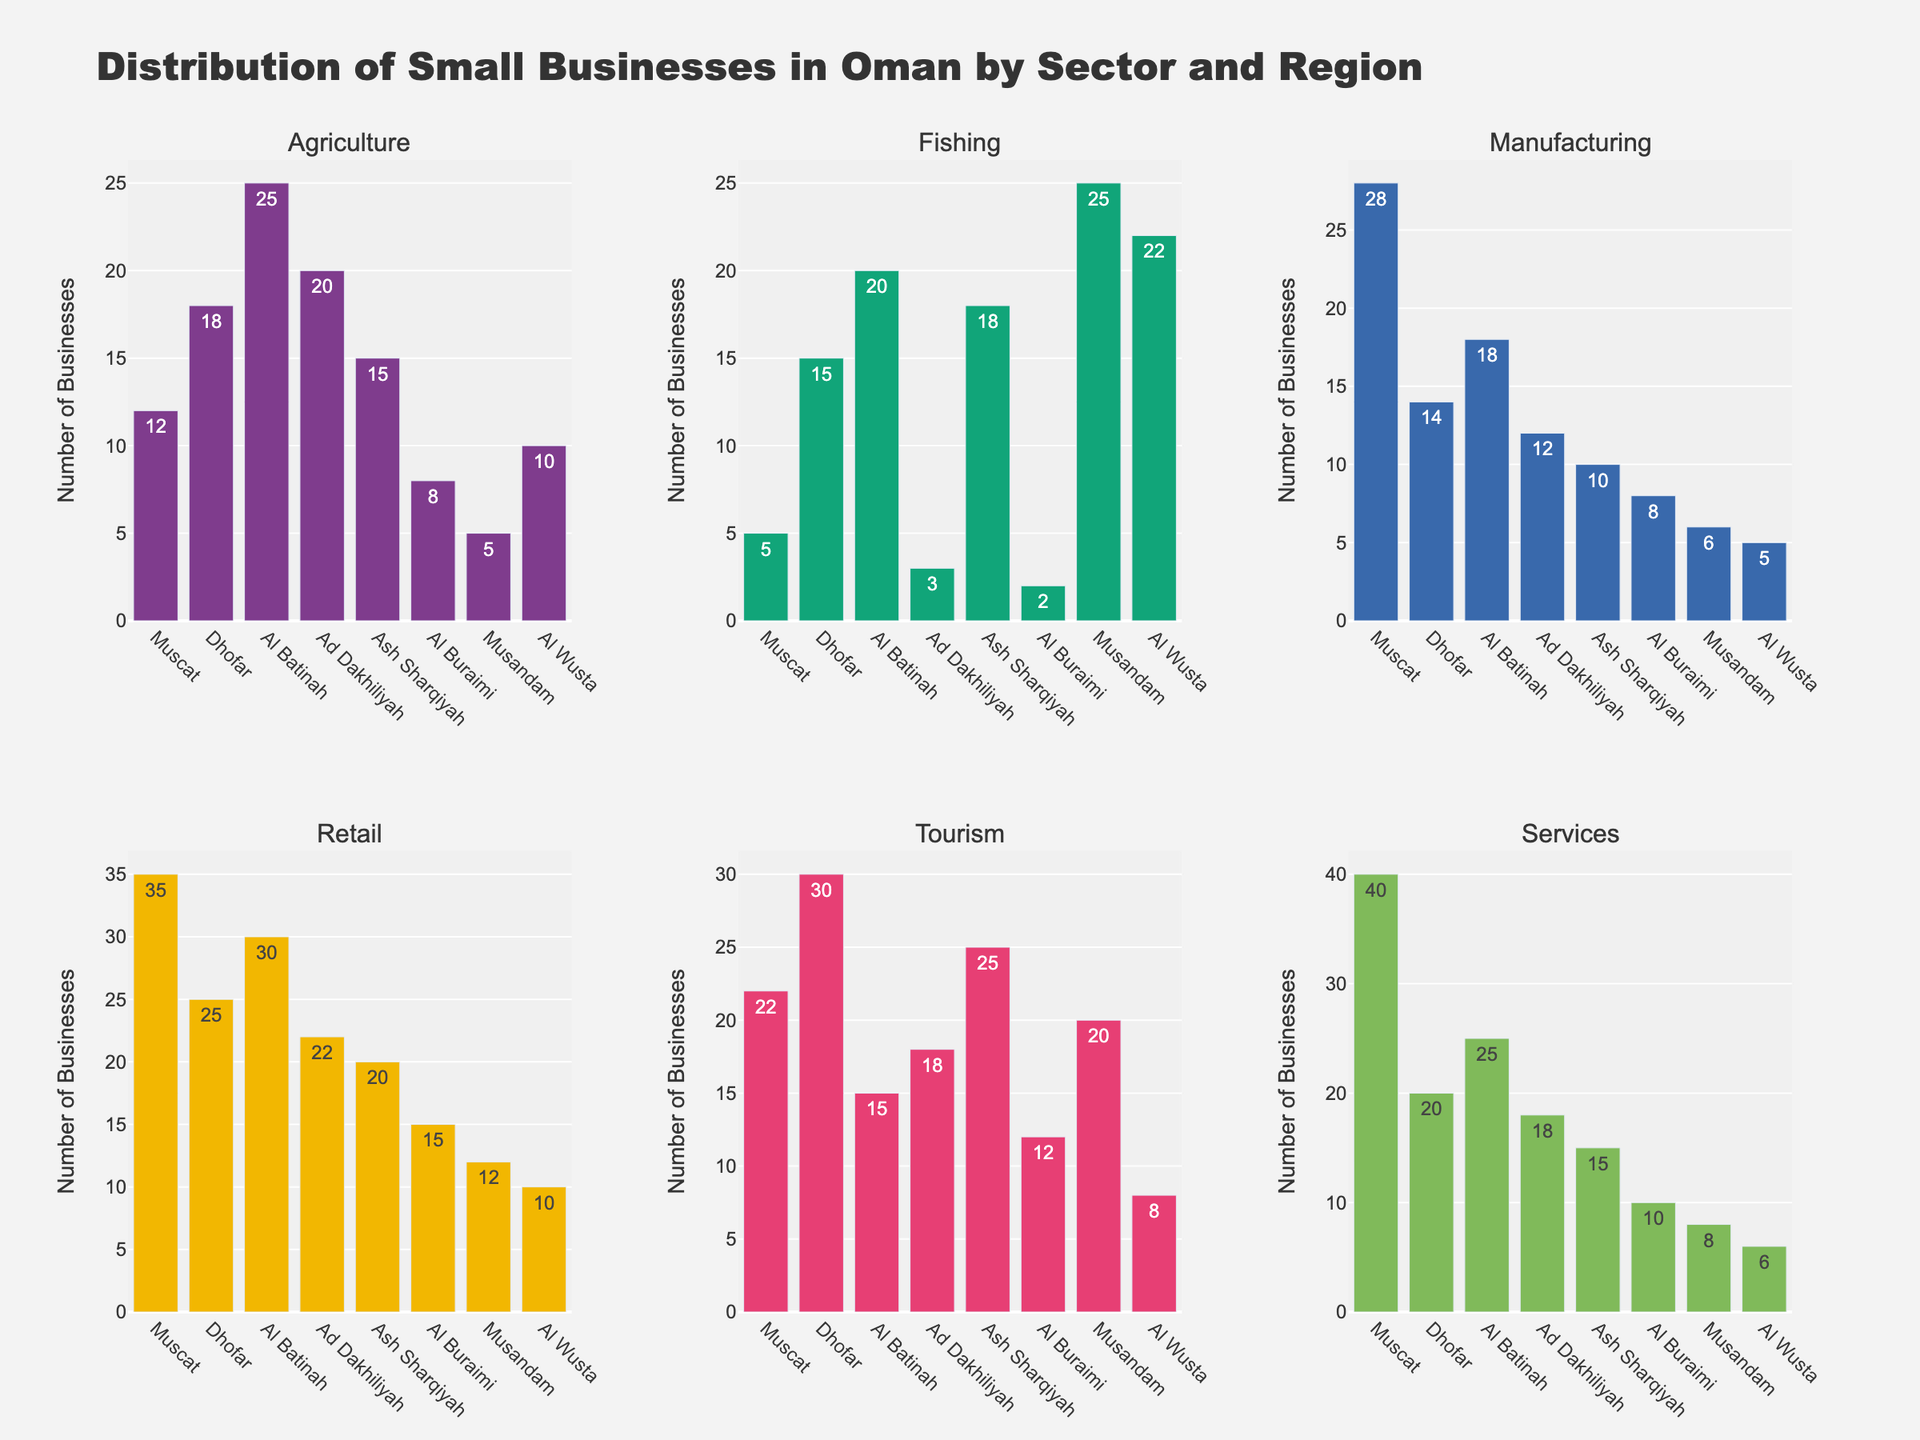Which sector in Muscat has the highest number of businesses? The figure shows bar graphs for different sectors and regions. For Muscat, we need to locate the tallest bar. The "Services" sector has the highest number at 40.
Answer: Services Which region has the most fishing businesses? To determine this, we look at the subplot for Fishing and identify the tallest bar, which belongs to Musandam with 25 fishing businesses.
Answer: Musandam How many total businesses are there in Dhofar across all sectors? Sum the number of businesses in Dhofar for each sector (Agriculture: 18, Fishing: 15, Manufacturing: 14, Retail: 25, Tourism: 30, Services: 20). The total is 18 + 15 + 14 + 25 + 30 + 20 = 122.
Answer: 122 Which sector has the least number of businesses in Al Wusta? By examining the bars for Al Wusta in each subplot, we see that "Services" with 6 businesses has the least number.
Answer: Services How does the number of manufacturing businesses in Al Batinah compare to that in Ad Dakhiliyah? The Manufacturing subplot shows 18 businesses in Al Batinah and 12 businesses in Ad Dakhiliyah. Al Batinah has more manufacturing businesses than Ad Dakhiliyah.
Answer: Al Batinah What's the difference in the number of tourism businesses between Ash Sharqiyah and Dhofar? The Tourism subplot shows 25 businesses in Ash Sharqiyah and 30 in Dhofar. The difference is 30 - 25 = 5.
Answer: 5 Which region has the highest number of agriculture businesses? By examining the Agriculture subplot, the highest bar is for Al Batinah with 25 agriculture businesses.
Answer: Al Batinah What is the average number of retail businesses across all regions? Sum the number of retail businesses (Muscat: 35, Dhofar: 25, Al Batinah: 30, Ad Dakhiliyah: 22, Ash Sharqiyah: 20, Al Buraimi: 15, Musandam: 12, Al Wusta: 10). The sum is 169. Divide by the number of regions (8), the average is 169/8 = 21.125.
Answer: 21.125 Which sector in Musandam has twice the number of businesses than agriculture? Look at the Agriculture bar for Musandam, which is 5. Doubling this is 10. The Fishing sector in Musandam has 25, which isn't twice, but we need to find an exact match so there isn't any sector with exactly half of 25.
Answer: None 